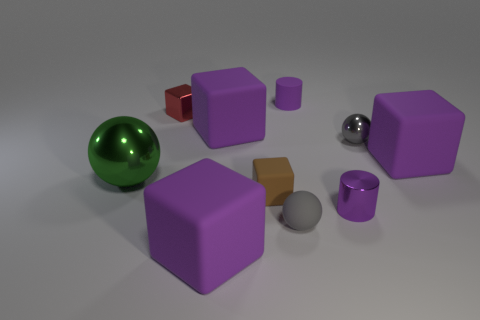How many purple cubes must be subtracted to get 1 purple cubes? 2 Subtract all brown balls. How many purple cubes are left? 3 Subtract all cylinders. How many objects are left? 8 Add 2 brown rubber blocks. How many brown rubber blocks are left? 3 Add 10 blue things. How many blue things exist? 10 Subtract 0 blue cylinders. How many objects are left? 10 Subtract all large brown metal balls. Subtract all purple rubber cubes. How many objects are left? 7 